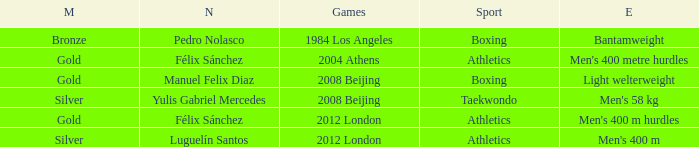Which Sport had an Event of men's 400 m hurdles? Athletics. 